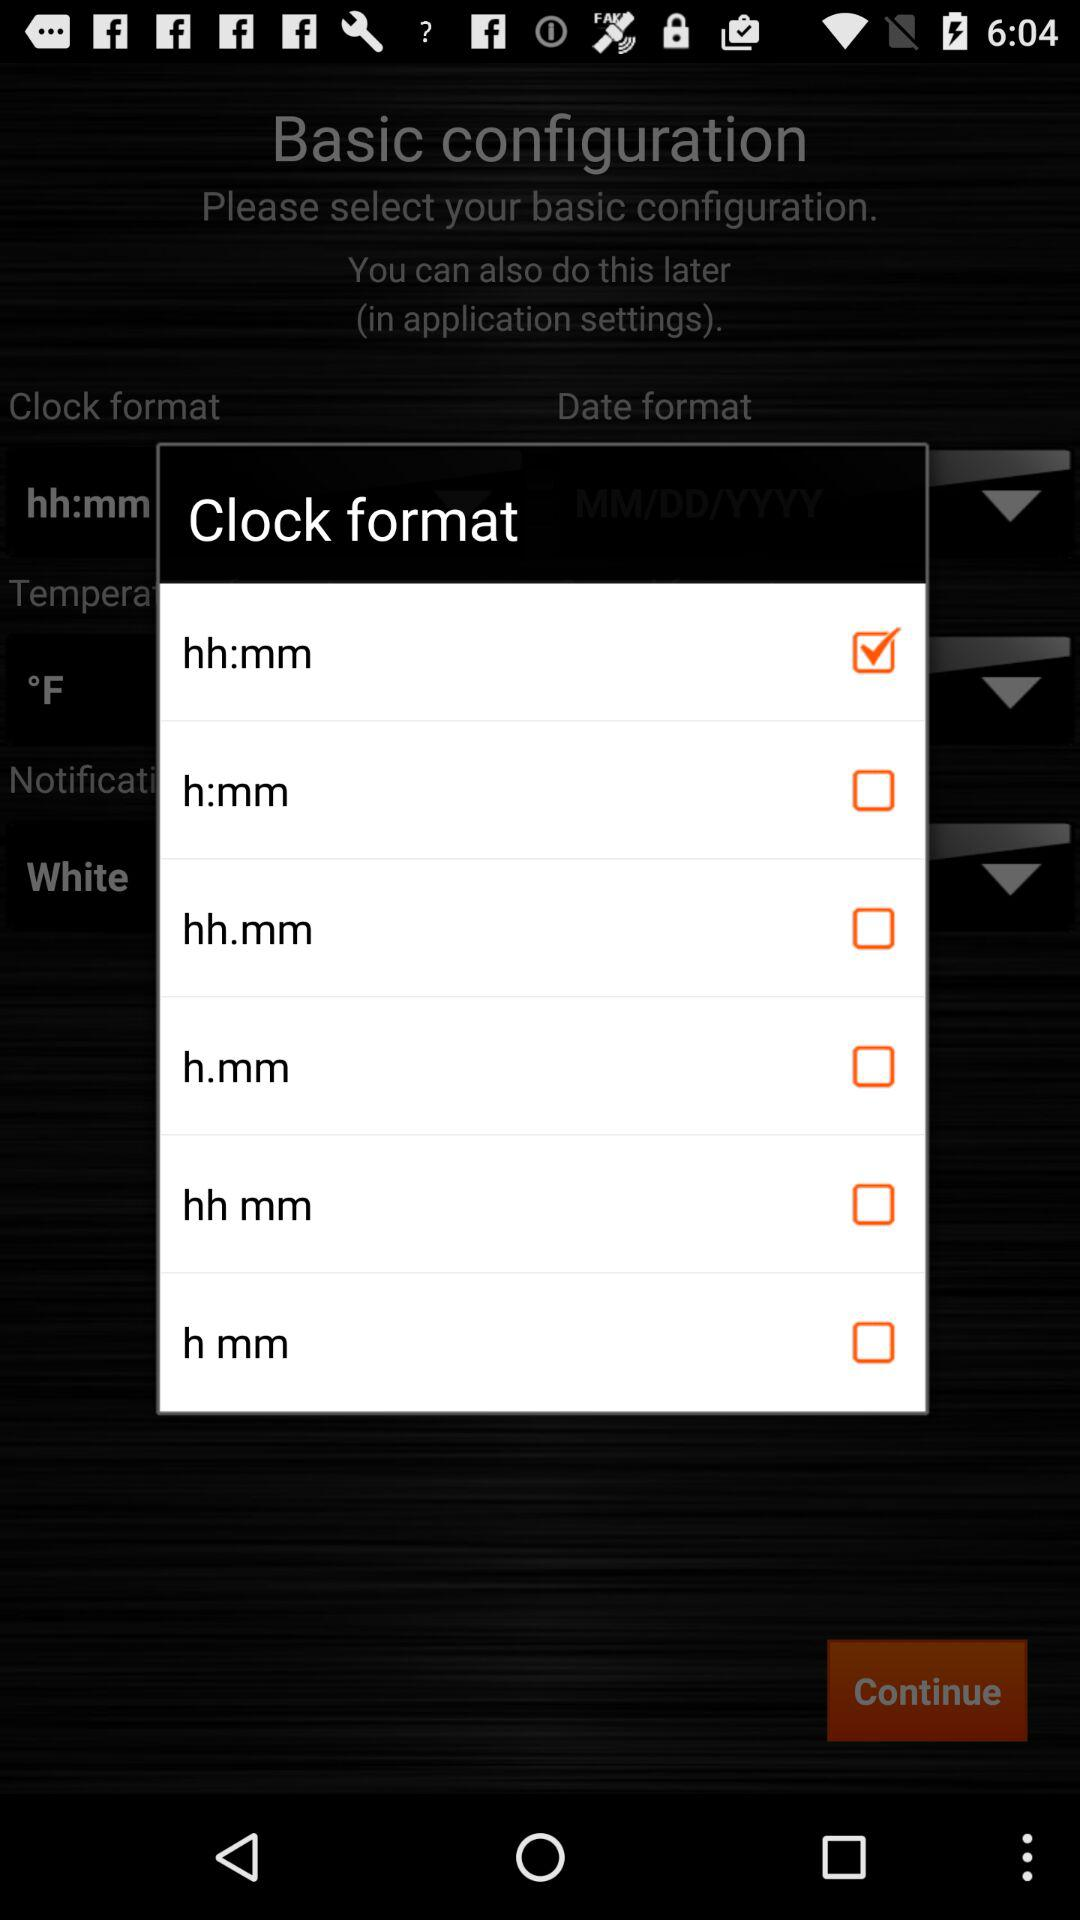Which clock format has been checked? The clock format that has been checked is "hh:mm". 